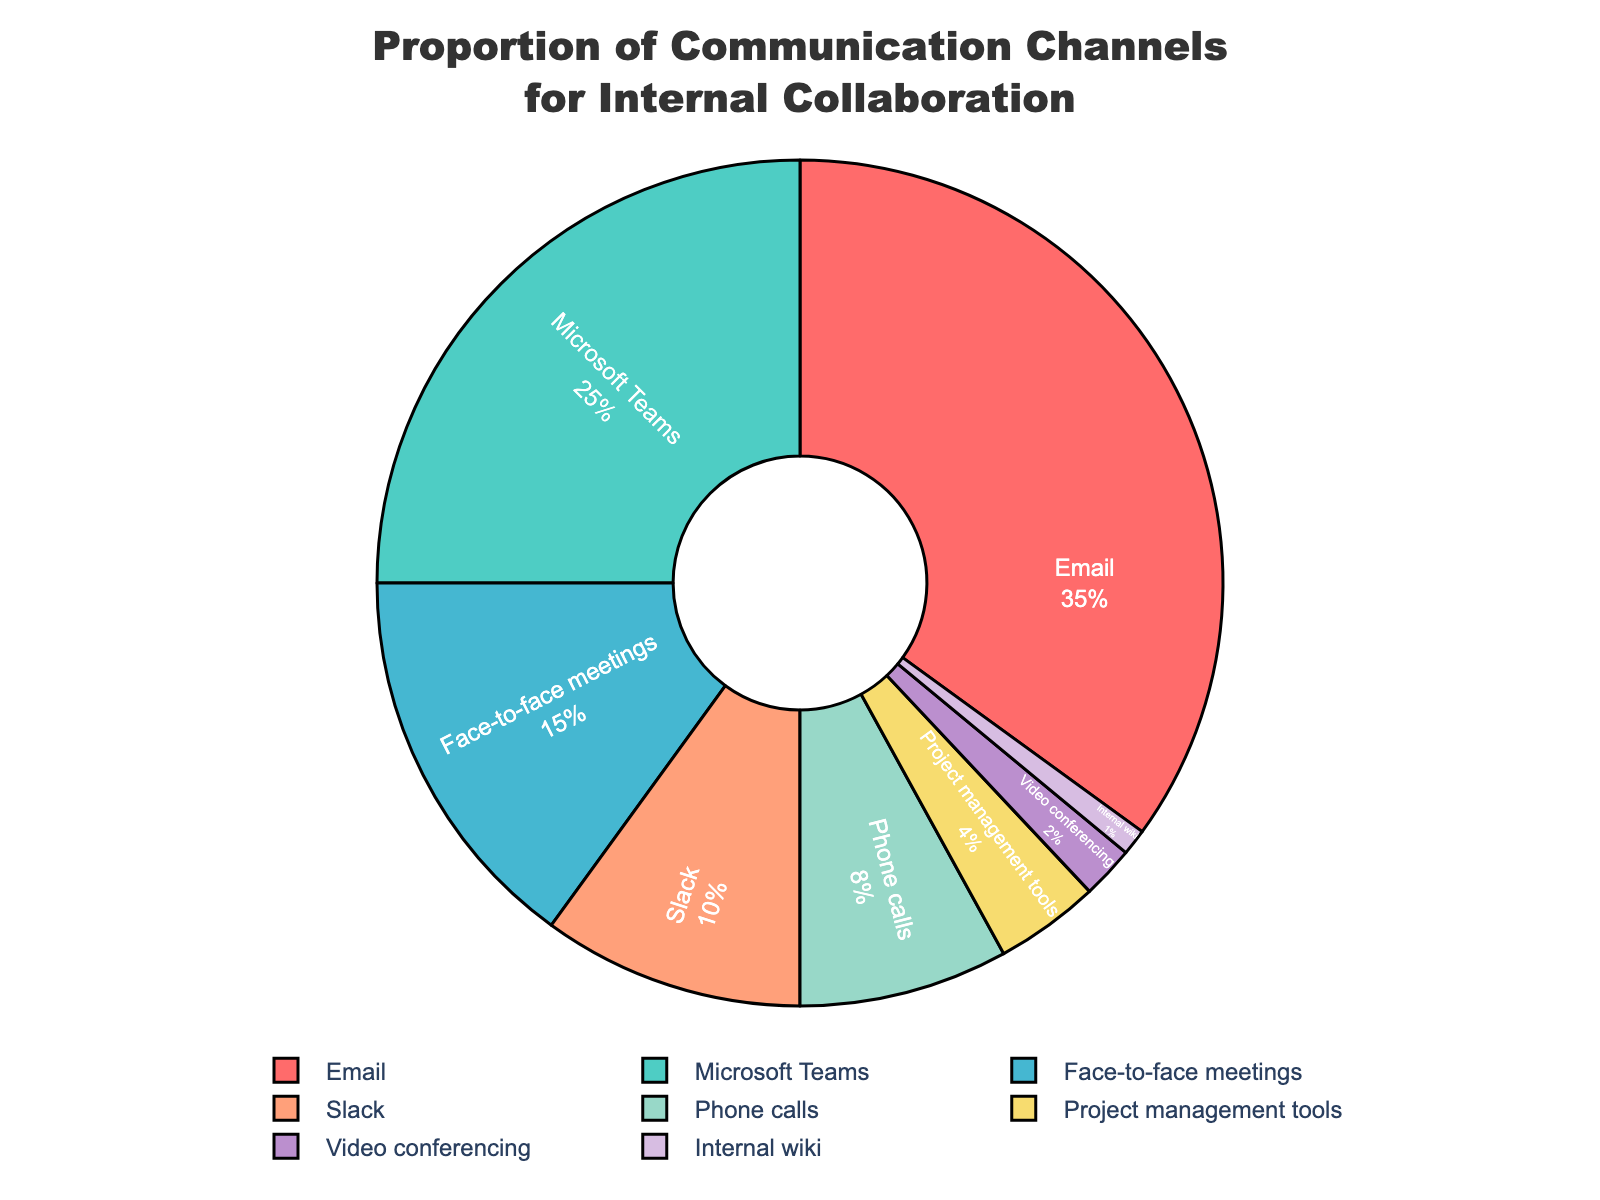Which communication channel is used the most for internal collaboration? To find the communication channel that is used the most, look at the segment with the largest portion in the pie chart. The segment labeled "Email" is the largest.
Answer: Email What is the combined percentage of communication channels with less than 10% usage each? Identify and sum the percentages of "Phone calls" (8%), "Project management tools" (4%), "Video conferencing" (2%), and "Internal wiki" (1%). The combined percentage is 8 + 4 + 2 + 1 = 15%.
Answer: 15% Which communication channels together account for more than half of the total usage? Determine the channels with percentages that sum to over 50%. "Email" (35%) and "Microsoft Teams" (25%) together make 35 + 25 = 60%, which is more than half.
Answer: Email and Microsoft Teams Which communication channel has the smallest segment in the pie chart and what is its percentage? Locate the smallest segment in the pie chart, which is labeled "Internal wiki" with a percentage of 1%.
Answer: Internal wiki, 1% How much more is the usage of Email compared to Face-to-face meetings? Identify the percentages for "Email" (35%) and "Face-to-face meetings" (15%). Subtract the smaller percentage from the larger one: 35 - 15 = 20%.
Answer: 20% Which communication channel is represented by the green segment, and what percentage does it cover? Identify the green segment and its label, which in the chart corresponds to "Microsoft Teams" with a percentage of 25%.
Answer: Microsoft Teams, 25% What is the average percentage usage of Slack, Phone calls, and Project management tools? Add the percentages of "Slack" (10%), "Phone calls" (8%), and "Project management tools" (4%) and then divide by the number of channels: (10 + 8 + 4)/3 = 7.33%.
Answer: 7.33% What's the difference in percentage points between Microsoft Teams and Video conferencing usage? Identify the percentages for "Microsoft Teams" (25%) and "Video conferencing" (2%). Subtract the smaller percentage from the larger one: 25 - 2 = 23%.
Answer: 23% If you combine the usage of Slack and Face-to-face meetings, how does their total compare to Email usage? Add the percentages for "Slack" (10%) and "Face-to-face meetings" (15%): 10 + 15 = 25%. Then compare it to "Email" (35%). 25% is less than 35%.
Answer: Less than What is the total usage percentage covered by the top three communication channels? Sum the percentages of the top three channels: "Email" (35%), "Microsoft Teams" (25%), and "Face-to-face meetings" (15%): 35 + 25 + 15 = 75%.
Answer: 75% 